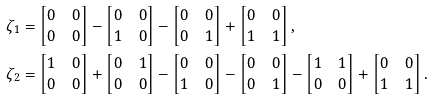Convert formula to latex. <formula><loc_0><loc_0><loc_500><loc_500>\zeta _ { 1 } & = \begin{bmatrix} 0 & 0 \\ 0 & 0 \end{bmatrix} - \begin{bmatrix} 0 & 0 \\ 1 & 0 \end{bmatrix} - \begin{bmatrix} 0 & 0 \\ 0 & 1 \end{bmatrix} + \begin{bmatrix} 0 & 0 \\ 1 & 1 \end{bmatrix} , \\ \zeta _ { 2 } & = \begin{bmatrix} 1 & 0 \\ 0 & 0 \end{bmatrix} + \begin{bmatrix} 0 & 1 \\ 0 & 0 \end{bmatrix} - \begin{bmatrix} 0 & 0 \\ 1 & 0 \end{bmatrix} - \begin{bmatrix} 0 & 0 \\ 0 & 1 \end{bmatrix} - \begin{bmatrix} 1 & 1 \\ 0 & 0 \end{bmatrix} + \begin{bmatrix} 0 & 0 \\ 1 & 1 \end{bmatrix} .</formula> 